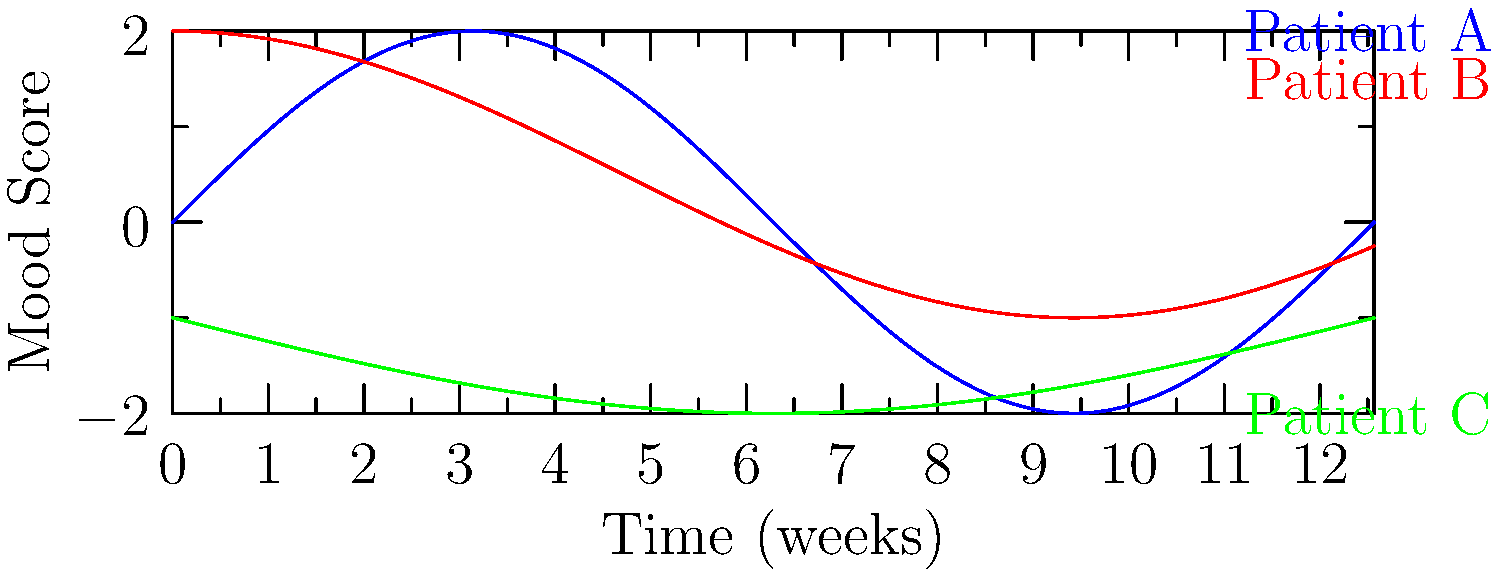The graph shows mood fluctuations for three patients over a 12-week period. Which patient exhibits the highest frequency of mood changes, and what might this suggest about their emotional stability compared to the others? To determine which patient has the highest frequency of mood changes, we need to analyze the number of cycles each patient's mood goes through in the given time period:

1. Patient A (blue line):
   - Completes about 2 full cycles in 12 weeks
   - Frequency ≈ 2 cycles / 12 weeks ≈ 0.167 cycles/week

2. Patient B (red line):
   - Completes about 1.5 cycles in 12 weeks
   - Frequency ≈ 1.5 cycles / 12 weeks ≈ 0.125 cycles/week

3. Patient C (green line):
   - Completes about 1 cycle in 12 weeks
   - Frequency ≈ 1 cycle / 12 weeks ≈ 0.083 cycles/week

Patient A has the highest frequency of mood changes, completing approximately 2 cycles in 12 weeks.

This higher frequency suggests that Patient A experiences more rapid mood fluctuations compared to the other patients. In terms of emotional stability:

1. Patient A may have less emotional stability, as their mood changes more frequently and rapidly.
2. Patient B shows moderate stability, with mood changes occurring less frequently than Patient A but more often than Patient C.
3. Patient C appears to have the most stable mood, with the slowest rate of change among the three patients.

The higher frequency of mood changes in Patient A could indicate:
- Greater emotional reactivity
- Possible bipolar disorder or cyclothymia
- Higher sensitivity to external factors affecting mood

It's important to note that while frequency of mood changes can be an indicator of emotional stability, other factors such as the amplitude of the changes and the overall trend should also be considered for a comprehensive assessment.
Answer: Patient A; suggests lower emotional stability due to more frequent mood fluctuations. 